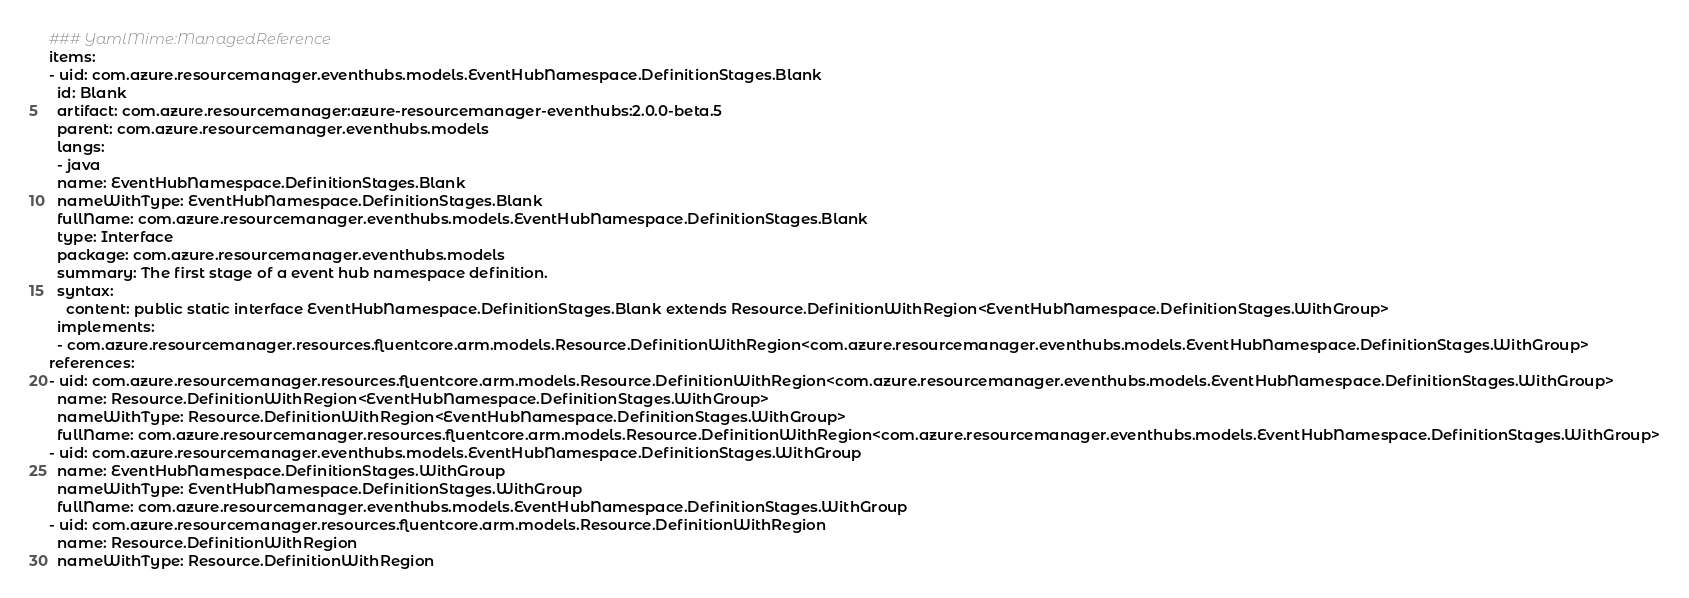<code> <loc_0><loc_0><loc_500><loc_500><_YAML_>### YamlMime:ManagedReference
items:
- uid: com.azure.resourcemanager.eventhubs.models.EventHubNamespace.DefinitionStages.Blank
  id: Blank
  artifact: com.azure.resourcemanager:azure-resourcemanager-eventhubs:2.0.0-beta.5
  parent: com.azure.resourcemanager.eventhubs.models
  langs:
  - java
  name: EventHubNamespace.DefinitionStages.Blank
  nameWithType: EventHubNamespace.DefinitionStages.Blank
  fullName: com.azure.resourcemanager.eventhubs.models.EventHubNamespace.DefinitionStages.Blank
  type: Interface
  package: com.azure.resourcemanager.eventhubs.models
  summary: The first stage of a event hub namespace definition.
  syntax:
    content: public static interface EventHubNamespace.DefinitionStages.Blank extends Resource.DefinitionWithRegion<EventHubNamespace.DefinitionStages.WithGroup>
  implements:
  - com.azure.resourcemanager.resources.fluentcore.arm.models.Resource.DefinitionWithRegion<com.azure.resourcemanager.eventhubs.models.EventHubNamespace.DefinitionStages.WithGroup>
references:
- uid: com.azure.resourcemanager.resources.fluentcore.arm.models.Resource.DefinitionWithRegion<com.azure.resourcemanager.eventhubs.models.EventHubNamespace.DefinitionStages.WithGroup>
  name: Resource.DefinitionWithRegion<EventHubNamespace.DefinitionStages.WithGroup>
  nameWithType: Resource.DefinitionWithRegion<EventHubNamespace.DefinitionStages.WithGroup>
  fullName: com.azure.resourcemanager.resources.fluentcore.arm.models.Resource.DefinitionWithRegion<com.azure.resourcemanager.eventhubs.models.EventHubNamespace.DefinitionStages.WithGroup>
- uid: com.azure.resourcemanager.eventhubs.models.EventHubNamespace.DefinitionStages.WithGroup
  name: EventHubNamespace.DefinitionStages.WithGroup
  nameWithType: EventHubNamespace.DefinitionStages.WithGroup
  fullName: com.azure.resourcemanager.eventhubs.models.EventHubNamespace.DefinitionStages.WithGroup
- uid: com.azure.resourcemanager.resources.fluentcore.arm.models.Resource.DefinitionWithRegion
  name: Resource.DefinitionWithRegion
  nameWithType: Resource.DefinitionWithRegion</code> 